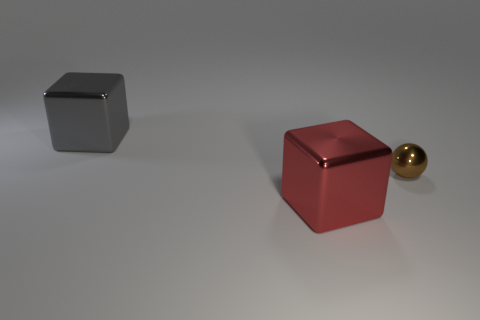Is there anything else that has the same size as the sphere?
Provide a short and direct response. No. Are there any other things that have the same size as the brown shiny object?
Your answer should be compact. No. Are the tiny brown ball and the big gray object made of the same material?
Ensure brevity in your answer.  Yes. What number of objects are either big gray shiny blocks or cyan objects?
Give a very brief answer. 1. What size is the red metal object?
Offer a terse response. Large. Are there fewer large gray objects than big purple metallic balls?
Your answer should be compact. No. How many other metallic objects have the same color as the small shiny object?
Give a very brief answer. 0. Is the color of the shiny cube behind the tiny thing the same as the tiny metal thing?
Your response must be concise. No. What is the shape of the big thing in front of the gray cube?
Keep it short and to the point. Cube. There is a big object in front of the gray metal thing; is there a big shiny block to the left of it?
Provide a short and direct response. Yes. 